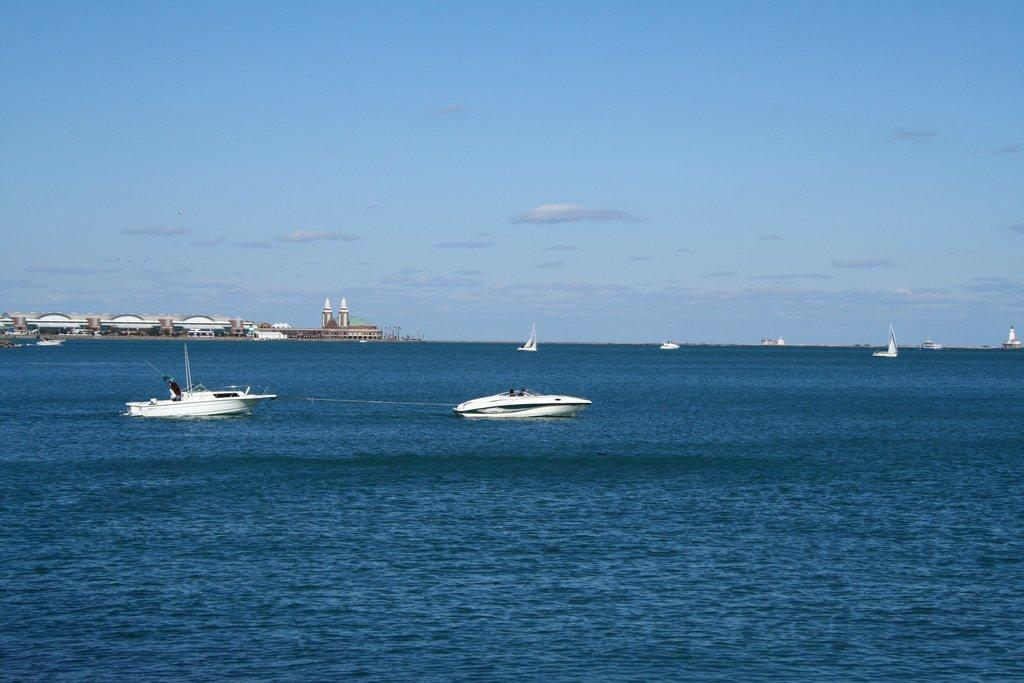What color is the water in the image? The water in the image is blue. What is floating on the surface of the water? There are red boats on the surface of the water. What can be seen in the distance in the image? There are buildings visible in the background of the image. What else is visible in the background of the image? The sky is visible in the background of the image. How does the nation affect the throat in the image? There is no nation or throat present in the image; it features water, red boats, buildings, and the sky. 